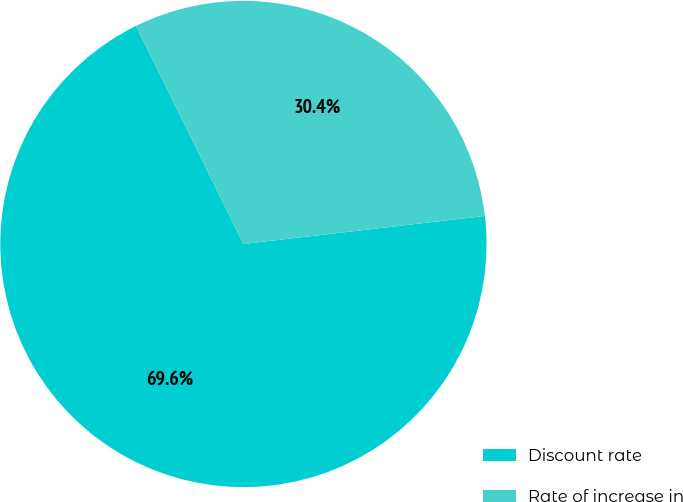<chart> <loc_0><loc_0><loc_500><loc_500><pie_chart><fcel>Discount rate<fcel>Rate of increase in<nl><fcel>69.56%<fcel>30.44%<nl></chart> 